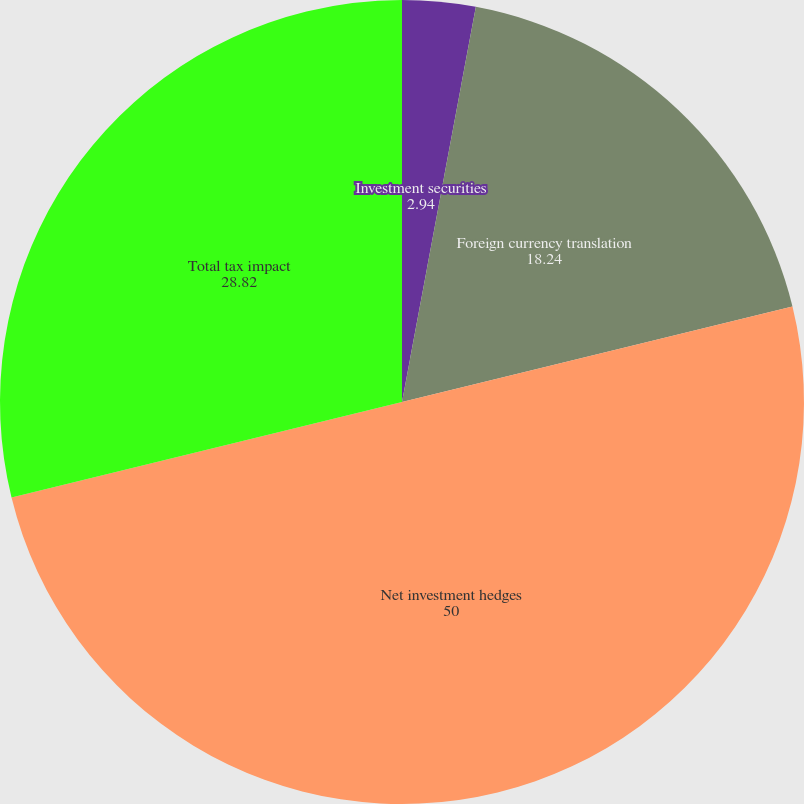Convert chart. <chart><loc_0><loc_0><loc_500><loc_500><pie_chart><fcel>Investment securities<fcel>Foreign currency translation<fcel>Net investment hedges<fcel>Total tax impact<nl><fcel>2.94%<fcel>18.24%<fcel>50.0%<fcel>28.82%<nl></chart> 